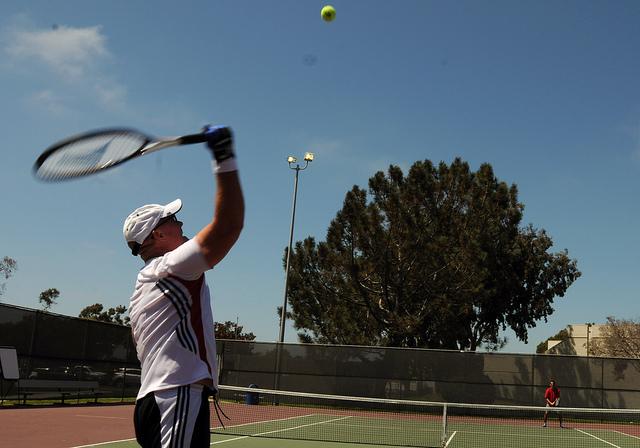What is the man doing?
Write a very short answer. Playing tennis. What is he going to hit the ball with?
Concise answer only. Racket. How many people are on the court?
Quick response, please. 2. What is in the air?
Concise answer only. Tennis ball. What is about to happen?
Be succinct. Hit ball. What type of field are they on?
Quick response, please. Tennis court. Why are the man's hands in the air?
Concise answer only. Swinging tennis racket. What is this man doing?
Write a very short answer. Tennis. What sport is this?
Answer briefly. Tennis. 